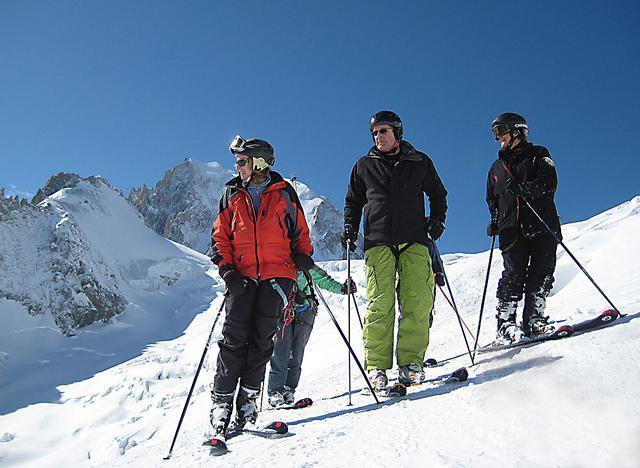How many clouds are in the sky?
Give a very brief answer. 0. How many skiers are there?
Give a very brief answer. 4. How many people are there?
Give a very brief answer. 4. How many black birds are sitting on the curved portion of the stone archway?
Give a very brief answer. 0. 